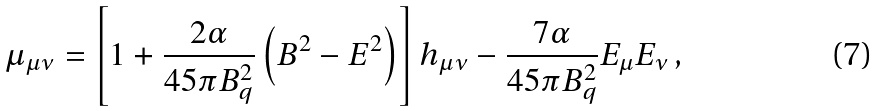<formula> <loc_0><loc_0><loc_500><loc_500>\mu _ { \mu \nu } = \left [ 1 + \frac { 2 \alpha } { 4 5 \pi B ^ { 2 } _ { q } } \left ( B ^ { 2 } - E ^ { 2 } \right ) \right ] h _ { \mu \nu } - \frac { 7 \alpha } { 4 5 \pi B ^ { 2 } _ { q } } E _ { \mu } E _ { \nu } \, ,</formula> 